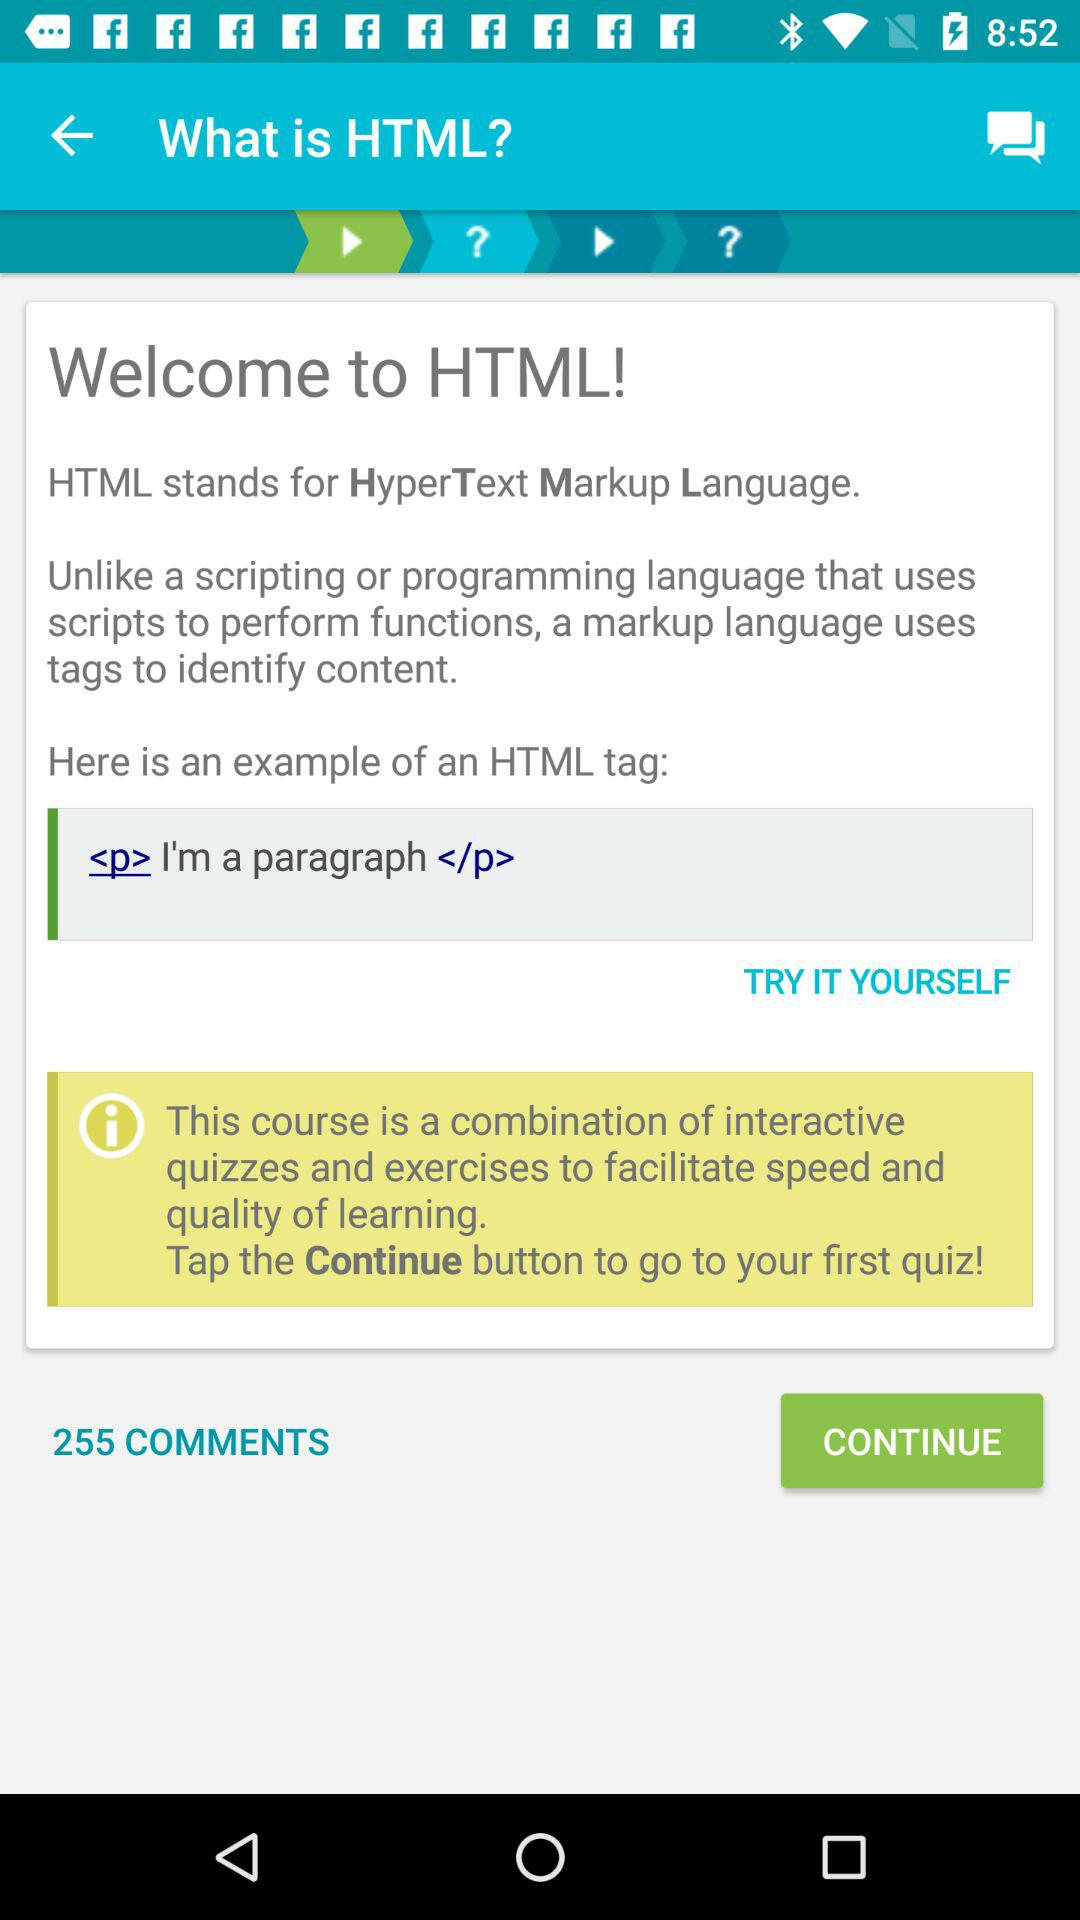What is the full form of HTML? The full form of HTML is HyperText Markup Language. 